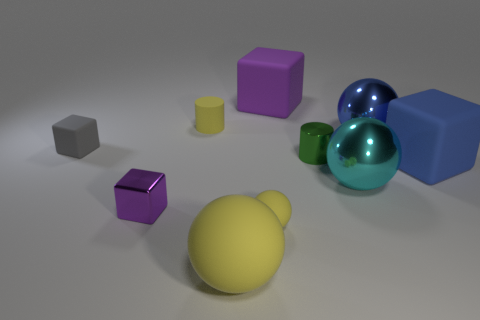Subtract 1 blocks. How many blocks are left? 3 Subtract all blocks. How many objects are left? 6 Subtract all small green cylinders. Subtract all small matte spheres. How many objects are left? 8 Add 9 gray things. How many gray things are left? 10 Add 7 tiny gray metallic spheres. How many tiny gray metallic spheres exist? 7 Subtract 0 cyan cylinders. How many objects are left? 10 